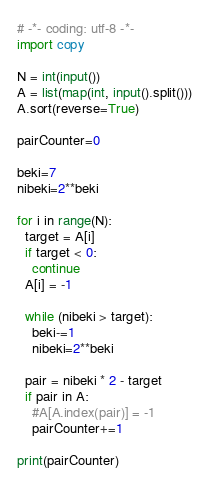Convert code to text. <code><loc_0><loc_0><loc_500><loc_500><_Python_># -*- coding: utf-8 -*-
import copy

N = int(input())
A = list(map(int, input().split()))
A.sort(reverse=True)

pairCounter=0

beki=7
nibeki=2**beki

for i in range(N):
  target = A[i]
  if target < 0:
    continue
  A[i] = -1  

  while (nibeki > target):
    beki-=1
    nibeki=2**beki

  pair = nibeki * 2 - target
  if pair in A:
    #A[A.index(pair)] = -1
    pairCounter+=1

print(pairCounter)</code> 